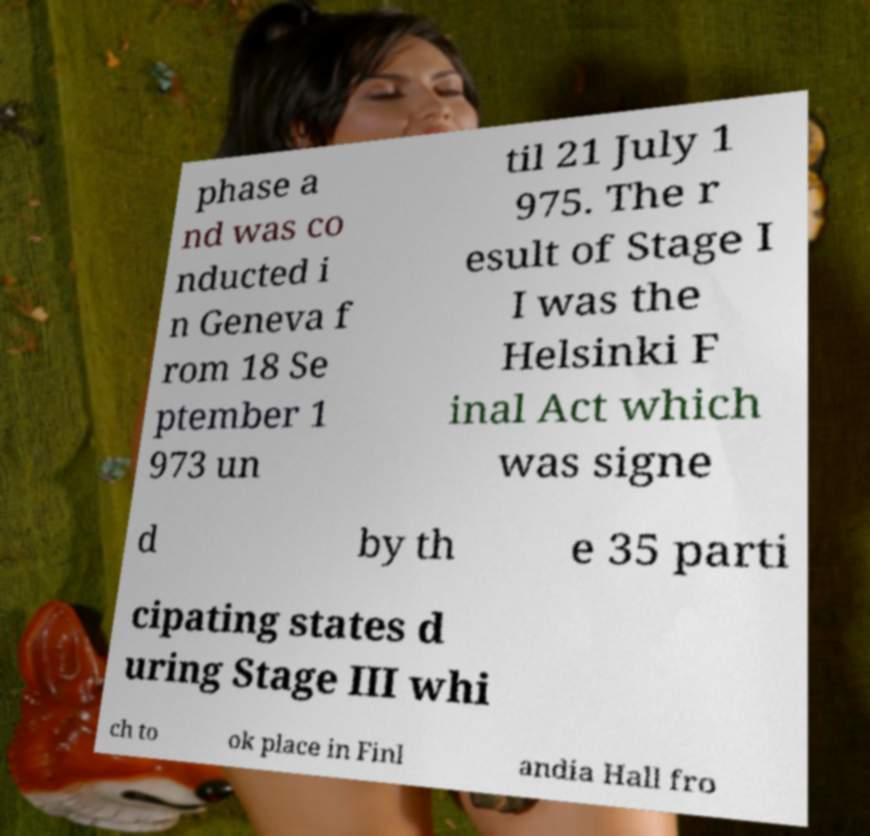What messages or text are displayed in this image? I need them in a readable, typed format. phase a nd was co nducted i n Geneva f rom 18 Se ptember 1 973 un til 21 July 1 975. The r esult of Stage I I was the Helsinki F inal Act which was signe d by th e 35 parti cipating states d uring Stage III whi ch to ok place in Finl andia Hall fro 